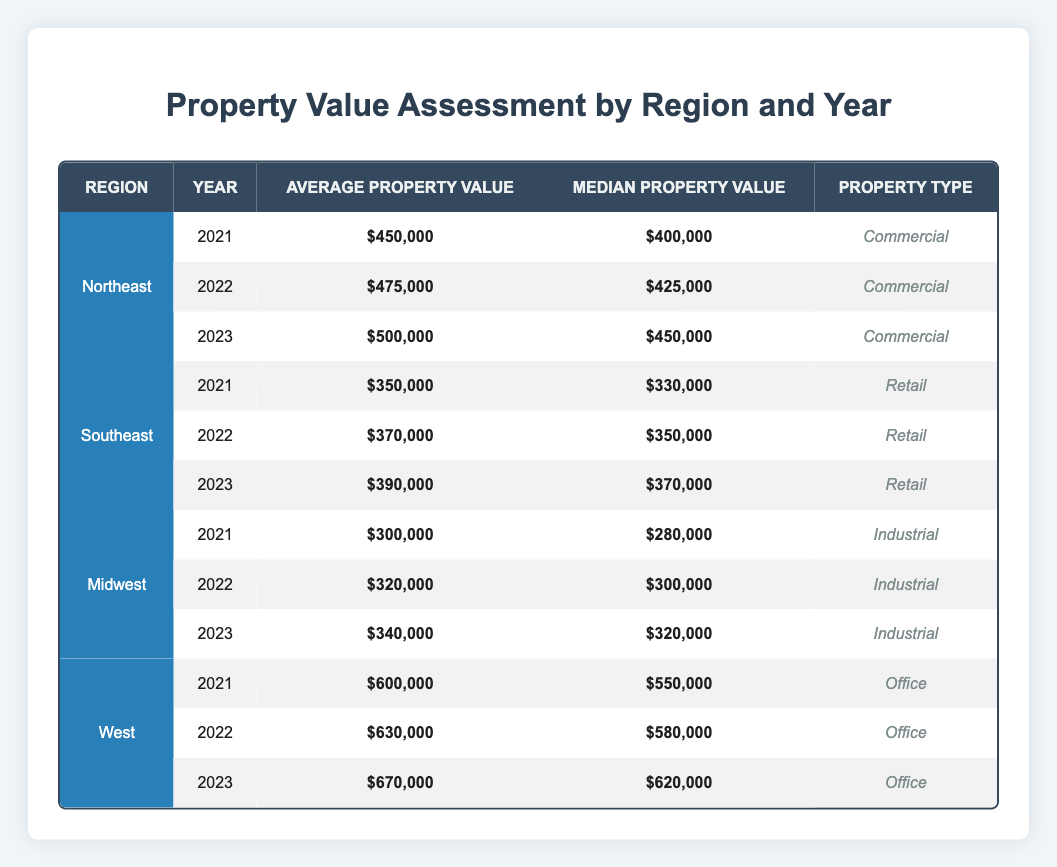What was the average property value in the Northeast region in 2023? According to the table, the average property value in the Northeast region for the year 2023 is listed as $500,000.
Answer: $500,000 What type of property had the highest median value in 2022? To find this, we compare the median values for all property types in 2022 from the table: Commercial ($425,000), Retail ($350,000), Industrial ($300,000), and Office ($580,000). The Office property type has the highest median value at $580,000.
Answer: Office What is the difference between the average property values in the Southeast region for 2021 and 2023? The average property values for the Southeast region were $350,000 in 2021 and $390,000 in 2023. The difference is calculated as $390,000 - $350,000 = $40,000.
Answer: $40,000 Is the median property value in the Midwest region increasing over the years? Reviewing the Midwest region's median values shows: 2021 ($280,000), 2022 ($300,000), and 2023 ($320,000). Since each subsequent year shows an increase in median value, the answer is yes.
Answer: Yes What was the average property value growth rate in the West region from 2021 to 2023? The average property values in the West region from 2021 to 2023 are $600,000 and $670,000, respectively. The growth can be calculated as follows: Growth = (New Value - Old Value) / Old Value = ($670,000 - $600,000) / $600,000 = $70,000 / $600,000 = 0.1167 (or 11.67%).
Answer: 11.67% What is the median property value for the Southeast region in 2022? The table indicates that the median property value for the Southeast region in 2022 is $350,000.
Answer: $350,000 Was there a decline in average property values in any region from 2021 to 2022? By examining the average property values: Northeast ($450,000 to $475,000), Southeast ($350,000 to $370,000), Midwest ($300,000 to $320,000), and West ($600,000 to $630,000), all regions show an increase, therefore, the answer is no.
Answer: No What is the total average property value in the Midwest region over the three years? Adding the average values for the Midwest region from 2021 ($300,000), 2022 ($320,000), and 2023 ($340,000) gives us a total of $300,000 + $320,000 + $340,000 = $960,000. The average is then calculated as $960,000 / 3 = $320,000.
Answer: $320,000 What property type showed the least growth in average value from 2021 to 2023? We compare the growth in average values for each property type over the three years: Northeast (from $450,000 to $500,000 = $50,000), Southeast (from $350,000 to $390,000 = $40,000), Midwest (from $300,000 to $340,000 = $40,000), and West (from $600,000 to $670,000 = $70,000). The Southeast and Midwest show the least growth of $40,000.
Answer: Southeast and Midwest 